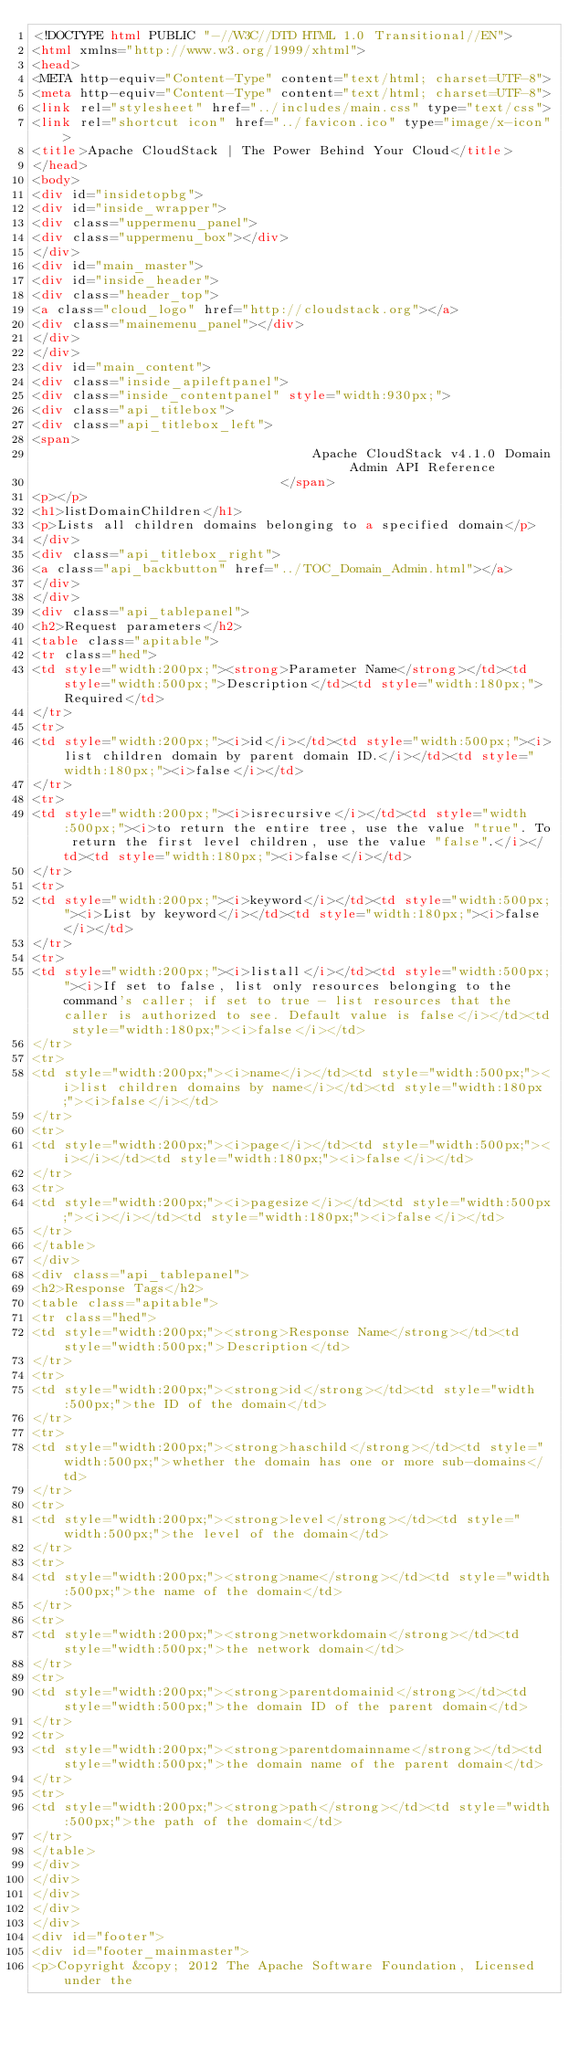<code> <loc_0><loc_0><loc_500><loc_500><_HTML_><!DOCTYPE html PUBLIC "-//W3C//DTD HTML 1.0 Transitional//EN">
<html xmlns="http://www.w3.org/1999/xhtml">
<head>
<META http-equiv="Content-Type" content="text/html; charset=UTF-8">
<meta http-equiv="Content-Type" content="text/html; charset=UTF-8">
<link rel="stylesheet" href="../includes/main.css" type="text/css">
<link rel="shortcut icon" href="../favicon.ico" type="image/x-icon">
<title>Apache CloudStack | The Power Behind Your Cloud</title>
</head>
<body>
<div id="insidetopbg">
<div id="inside_wrapper">
<div class="uppermenu_panel">
<div class="uppermenu_box"></div>
</div>
<div id="main_master">
<div id="inside_header">
<div class="header_top">
<a class="cloud_logo" href="http://cloudstack.org"></a>
<div class="mainemenu_panel"></div>
</div>
</div>
<div id="main_content">
<div class="inside_apileftpanel">
<div class="inside_contentpanel" style="width:930px;">
<div class="api_titlebox">
<div class="api_titlebox_left">
<span>
									Apache CloudStack v4.1.0 Domain Admin API Reference
								</span>
<p></p>
<h1>listDomainChildren</h1>
<p>Lists all children domains belonging to a specified domain</p>
</div>
<div class="api_titlebox_right">
<a class="api_backbutton" href="../TOC_Domain_Admin.html"></a>
</div>
</div>
<div class="api_tablepanel">
<h2>Request parameters</h2>
<table class="apitable">
<tr class="hed">
<td style="width:200px;"><strong>Parameter Name</strong></td><td style="width:500px;">Description</td><td style="width:180px;">Required</td>
</tr>
<tr>
<td style="width:200px;"><i>id</i></td><td style="width:500px;"><i>list children domain by parent domain ID.</i></td><td style="width:180px;"><i>false</i></td>
</tr>
<tr>
<td style="width:200px;"><i>isrecursive</i></td><td style="width:500px;"><i>to return the entire tree, use the value "true". To return the first level children, use the value "false".</i></td><td style="width:180px;"><i>false</i></td>
</tr>
<tr>
<td style="width:200px;"><i>keyword</i></td><td style="width:500px;"><i>List by keyword</i></td><td style="width:180px;"><i>false</i></td>
</tr>
<tr>
<td style="width:200px;"><i>listall</i></td><td style="width:500px;"><i>If set to false, list only resources belonging to the command's caller; if set to true - list resources that the caller is authorized to see. Default value is false</i></td><td style="width:180px;"><i>false</i></td>
</tr>
<tr>
<td style="width:200px;"><i>name</i></td><td style="width:500px;"><i>list children domains by name</i></td><td style="width:180px;"><i>false</i></td>
</tr>
<tr>
<td style="width:200px;"><i>page</i></td><td style="width:500px;"><i></i></td><td style="width:180px;"><i>false</i></td>
</tr>
<tr>
<td style="width:200px;"><i>pagesize</i></td><td style="width:500px;"><i></i></td><td style="width:180px;"><i>false</i></td>
</tr>
</table>
</div>
<div class="api_tablepanel">
<h2>Response Tags</h2>
<table class="apitable">
<tr class="hed">
<td style="width:200px;"><strong>Response Name</strong></td><td style="width:500px;">Description</td>
</tr>
<tr>
<td style="width:200px;"><strong>id</strong></td><td style="width:500px;">the ID of the domain</td>
</tr>
<tr>
<td style="width:200px;"><strong>haschild</strong></td><td style="width:500px;">whether the domain has one or more sub-domains</td>
</tr>
<tr>
<td style="width:200px;"><strong>level</strong></td><td style="width:500px;">the level of the domain</td>
</tr>
<tr>
<td style="width:200px;"><strong>name</strong></td><td style="width:500px;">the name of the domain</td>
</tr>
<tr>
<td style="width:200px;"><strong>networkdomain</strong></td><td style="width:500px;">the network domain</td>
</tr>
<tr>
<td style="width:200px;"><strong>parentdomainid</strong></td><td style="width:500px;">the domain ID of the parent domain</td>
</tr>
<tr>
<td style="width:200px;"><strong>parentdomainname</strong></td><td style="width:500px;">the domain name of the parent domain</td>
</tr>
<tr>
<td style="width:200px;"><strong>path</strong></td><td style="width:500px;">the path of the domain</td>
</tr>
</table>
</div>
</div>
</div>
</div>
</div>
<div id="footer">
<div id="footer_mainmaster">
<p>Copyright &copy; 2012 The Apache Software Foundation, Licensed under the</code> 